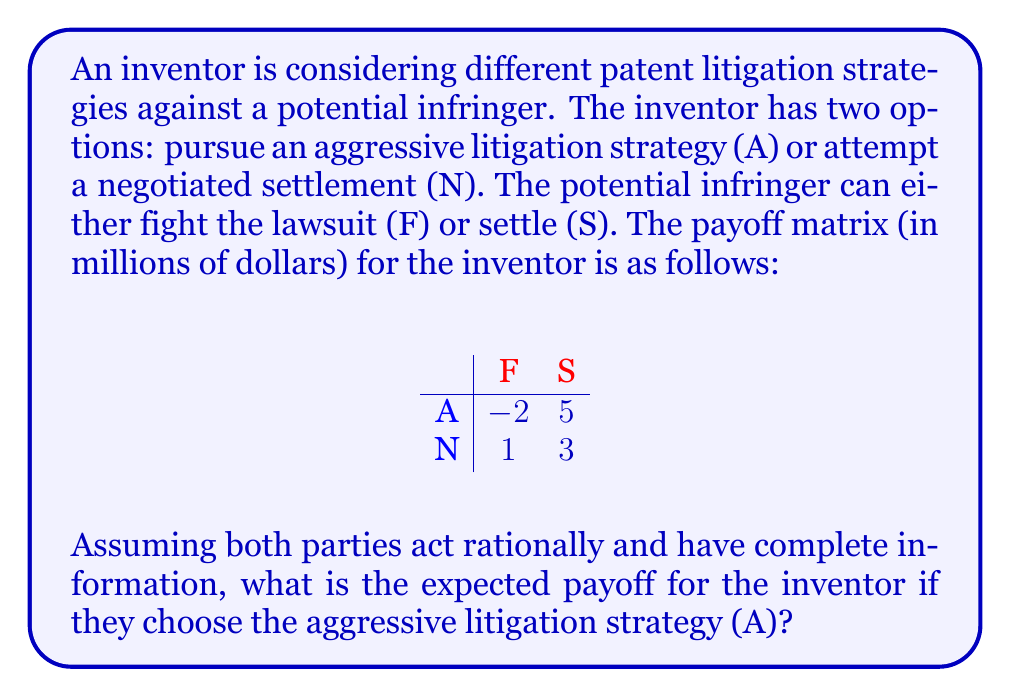Help me with this question. To solve this problem, we need to use the concept of mixed strategies from game theory. Since the potential infringer has complete information, they will choose the strategy that minimizes the inventor's payoff.

1) If the inventor chooses strategy A:
   - If the infringer chooses F, the payoff is -2
   - If the infringer chooses S, the payoff is 5

2) The infringer will choose F to minimize the inventor's payoff when the inventor chooses A.

3) Therefore, the expected payoff for the inventor when choosing strategy A is -2 million dollars.

This analysis assumes that both parties are acting rationally and have complete information. In real-world patent litigation scenarios, there might be additional factors to consider, such as reputation effects, legal costs, and the potential for future negotiations.
Answer: The expected payoff for the inventor if they choose the aggressive litigation strategy (A) is $-2$ million dollars. 